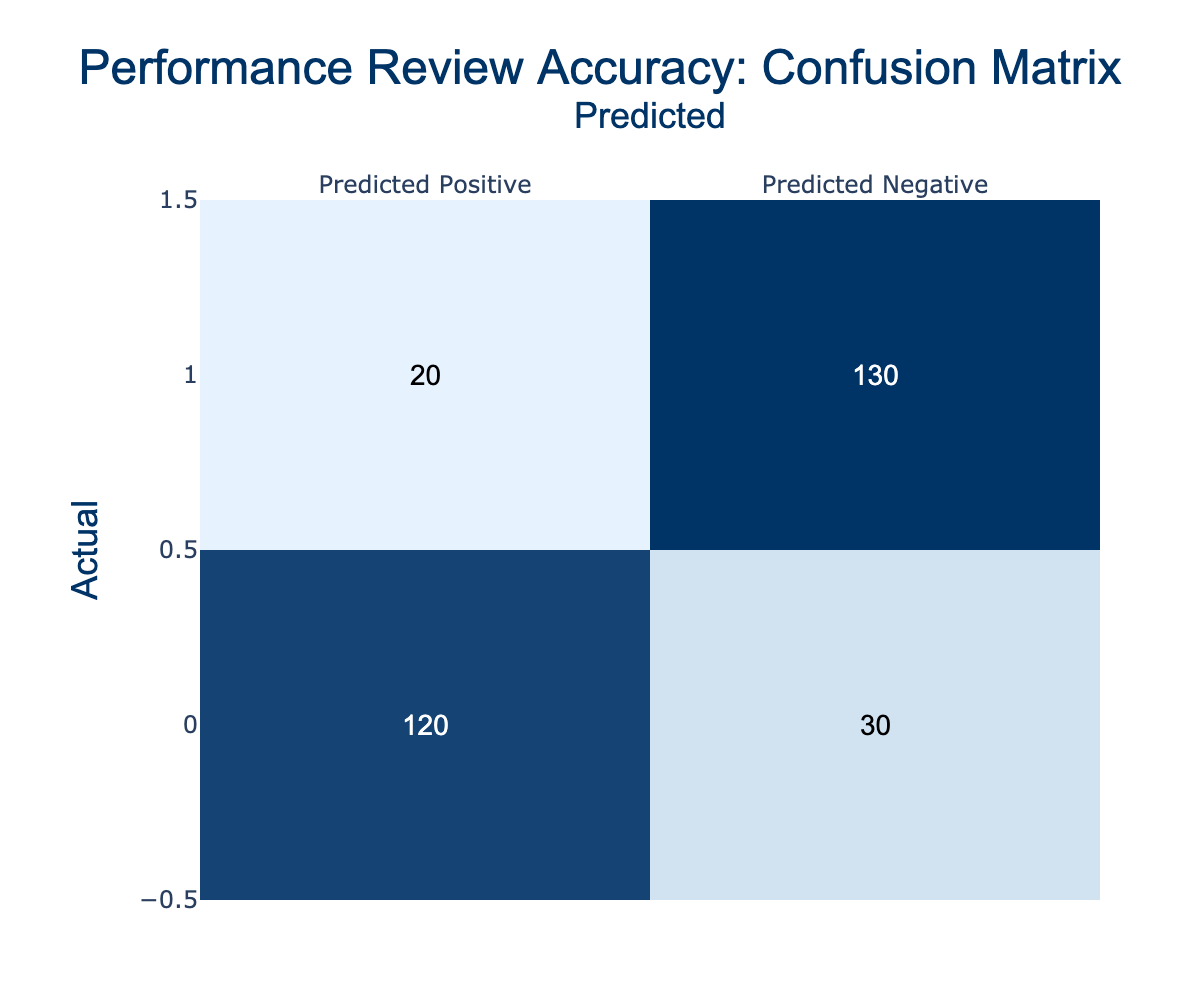What is the number of true positives? True positives are indicated as the count of actual positives that were correctly predicted as positive. From the table, the value in the "Actual Positive" row and "Predicted Positive" column is 120.
Answer: 120 What is the number of false negatives? False negatives are represented by the count of actual positives that were incorrectly predicted as negatives. According to the table, this is the value in the "Actual Positive" row and "Predicted Negative" column, which is 30.
Answer: 30 What is the total number of actual negatives? To find the total number of actual negatives, we need to sum the counts of predictions for actual negatives. Thus, we add the values in the "Actual Negative" row: 20 (predicted positive) + 130 (predicted negative) = 150.
Answer: 150 Is the number of true positives greater than the number of false negatives? We compare the true positive count (120) with the false negative count (30). Since 120 is greater than 30, the statement is true.
Answer: Yes What is the total accuracy of the predictions? Total accuracy is calculated by dividing the total number of correct predictions (true positives + true negatives) by the total number of actual instances. First, we calculate true negatives (130) and then find total instances: 120 (true positives) + 30 (false negatives) + 20 (false positives) + 130 (true negatives) = 300. The calculation is (120 + 130) / 300 = 0.8333, which can also be expressed as 83.33%.
Answer: 83.33% What is the number of false positives? False positives are defined as actual negatives that were incorrectly predicted as positives. From the table, this is the value found in the "Actual Negative" row and "Predicted Positive" column, which is 20.
Answer: 20 How many total positives were predicted? To determine total positives predicted, we add the number of true positives and false positives together: 120 (true positives) + 20 (false positives) = 140.
Answer: 140 What percentage of actual positives were correctly identified? To find this percentage, we calculate the ratio of true positives to actual positives. The total actual positives is 120 (true positives) + 30 (false negatives) = 150. The calculation is (120/150) * 100 = 80%.
Answer: 80% How many total instances are there? The total instances can be calculated by summing all values in the confusion matrix: 120 (true positive) + 30 (false negative) + 20 (false positive) + 130 (true negative) = 300.
Answer: 300 